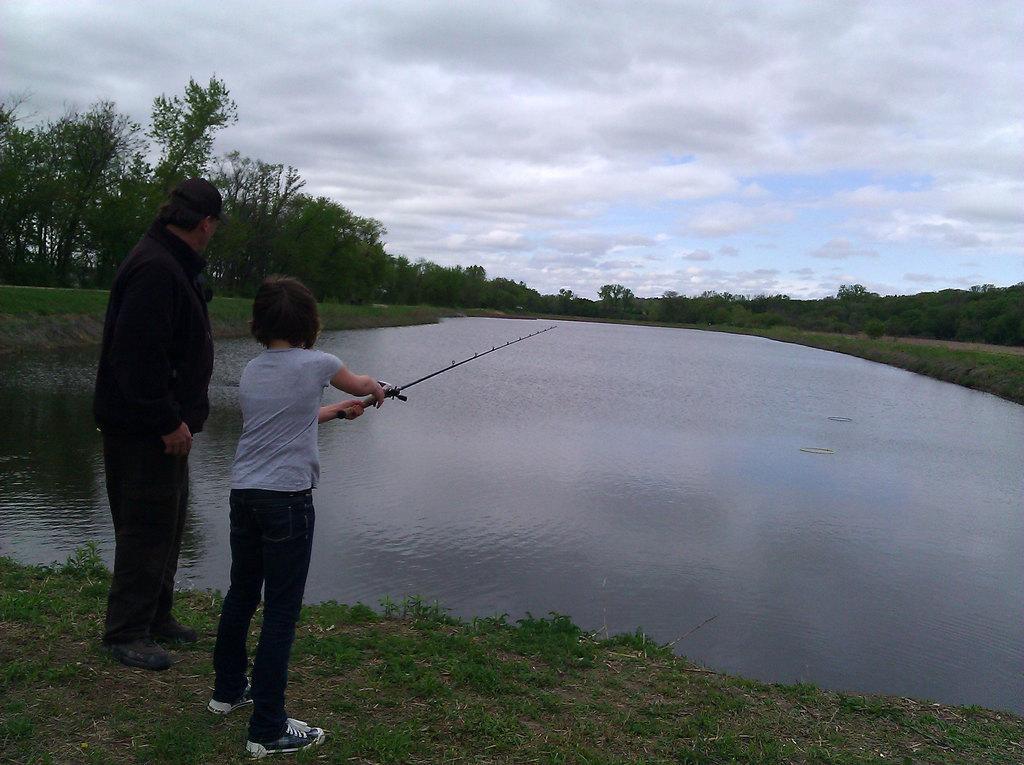Describe this image in one or two sentences. There are two people standing and this kid holding a fishing rod. We can see water and grass. In the background we can see trees and sky with clouds 